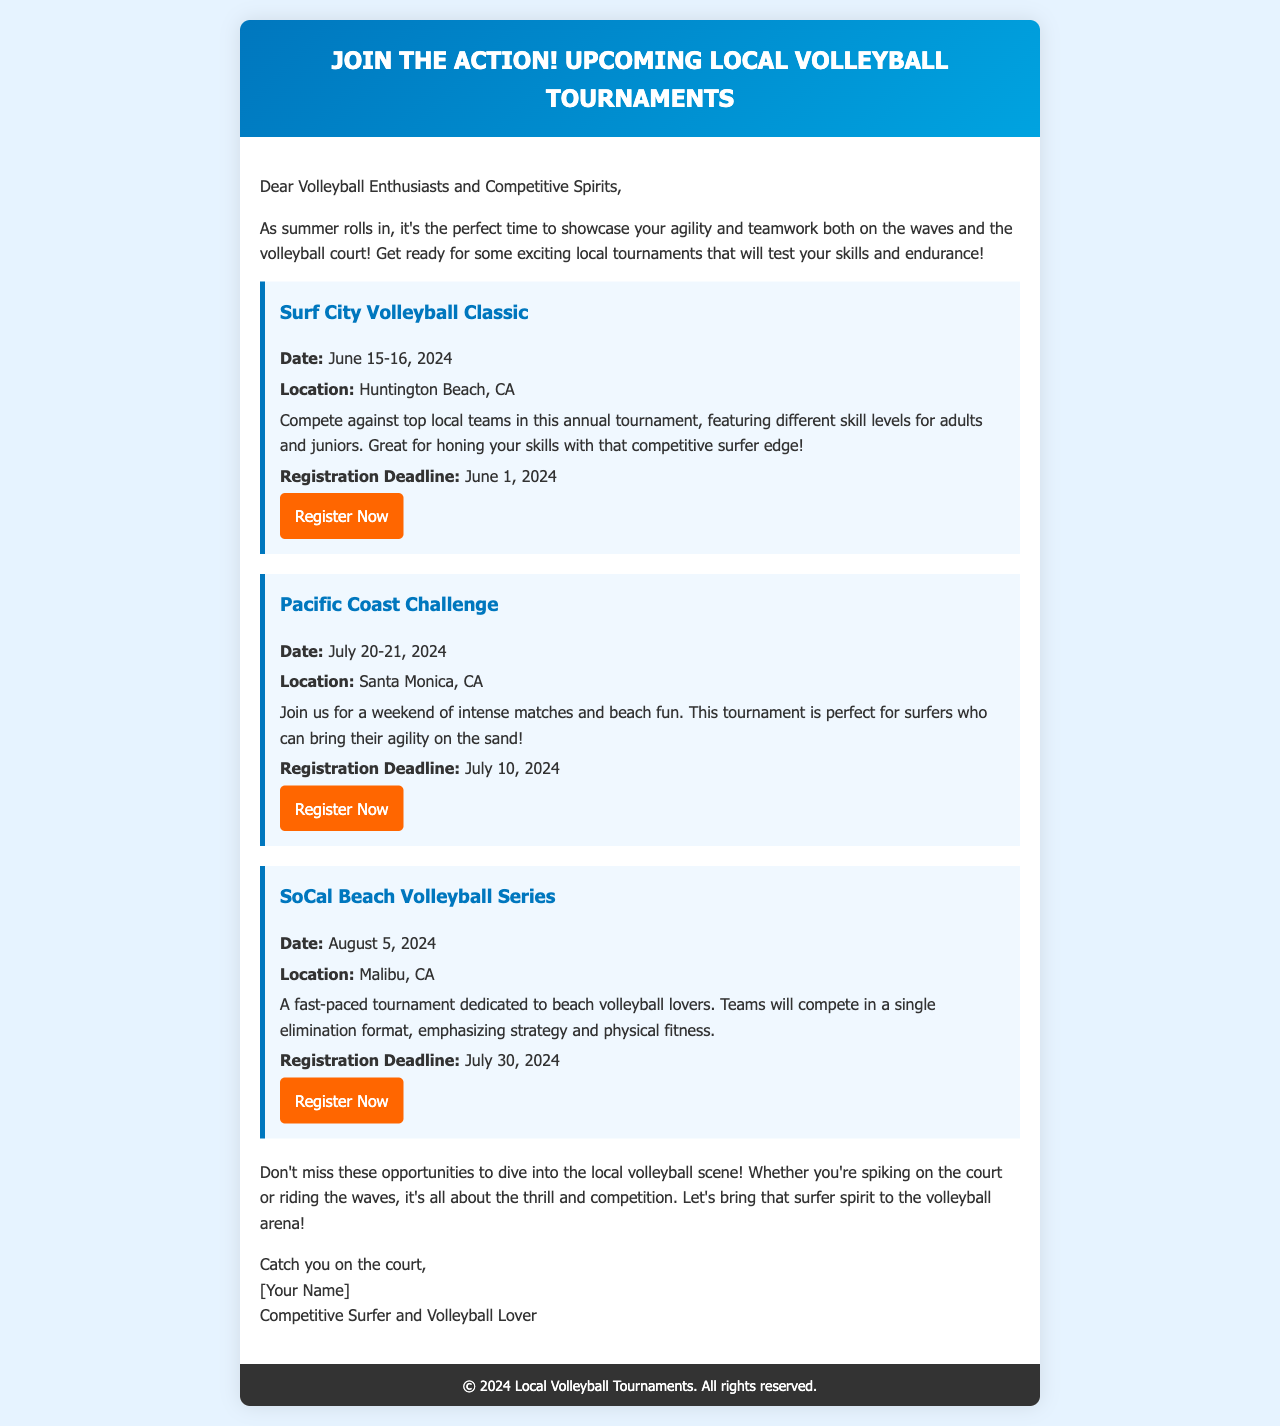What is the date of the Surf City Volleyball Classic? The date of the Surf City Volleyball Classic is mentioned as June 15-16, 2024.
Answer: June 15-16, 2024 Where is the Pacific Coast Challenge being held? The location of the Pacific Coast Challenge is Santa Monica, CA, as stated in the document.
Answer: Santa Monica, CA What is the registration deadline for the SoCal Beach Volleyball Series? The registration deadline for the SoCal Beach Volleyball Series is July 30, 2024, as indicated in the document.
Answer: July 30, 2024 What kind of format is used in the SoCal Beach Volleyball Series? The document describes the format for the SoCal Beach Volleyball Series as single elimination.
Answer: Single elimination Which tournament emphasizes strategy and physical fitness? The document states that the SoCal Beach Volleyball Series emphasizes strategy and physical fitness.
Answer: SoCal Beach Volleyball Series How many tournaments are mentioned in the email? The email mentions three upcoming tournaments for participants.
Answer: Three What is the primary motivation for joining these tournaments according to the document? The document encourages participation by highlighting the thrill of competition and showcasing skills.
Answer: Thrill of competition What is the primary audience for this email? The email addresses "Volleyball Enthusiasts and Competitive Spirits" as its main audience.
Answer: Volleyball Enthusiasts and Competitive Spirits Which tournament is specifically noted for being suitable for surfers? The document notes that both the Surf City Volleyball Classic and the Pacific Coast Challenge are suitable for surfers, but emphasizes this for the Pacific Coast Challenge.
Answer: Pacific Coast Challenge 